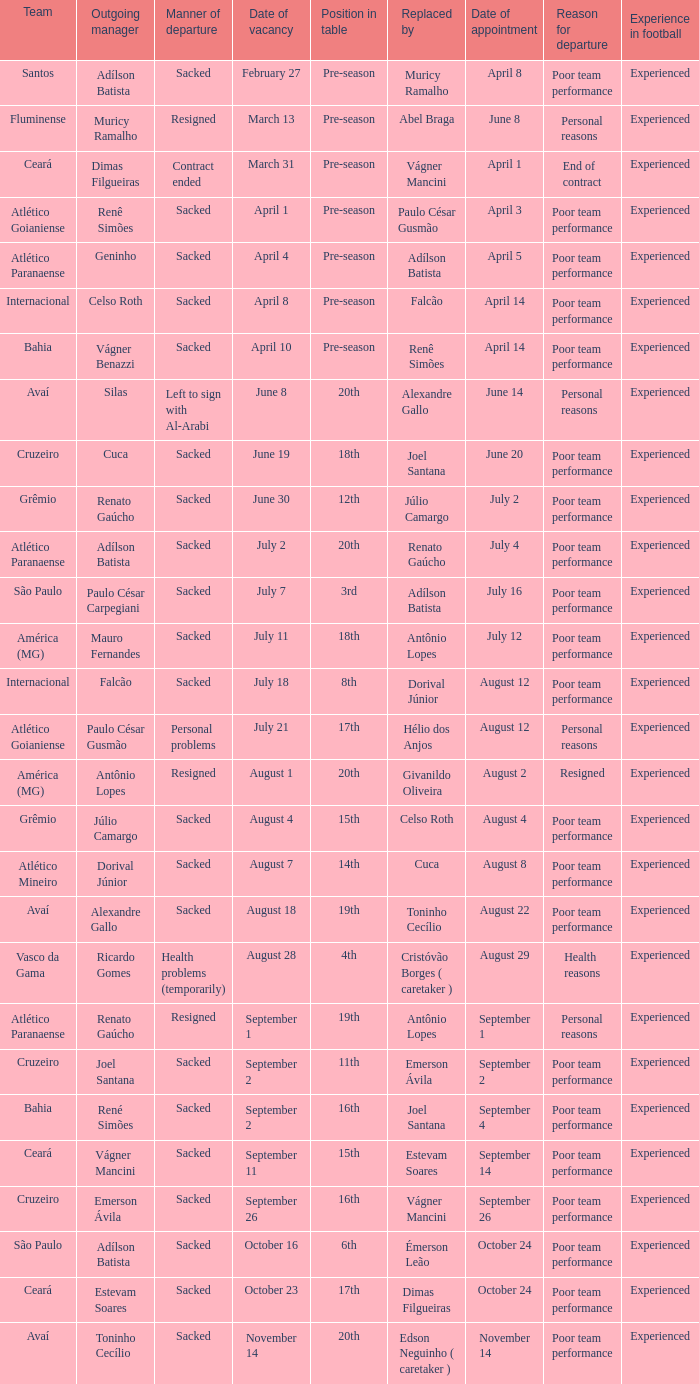What team hired Renato Gaúcho? Atlético Paranaense. Could you help me parse every detail presented in this table? {'header': ['Team', 'Outgoing manager', 'Manner of departure', 'Date of vacancy', 'Position in table', 'Replaced by', 'Date of appointment', 'Reason for departure', 'Experience in football'], 'rows': [['Santos', 'Adílson Batista', 'Sacked', 'February 27', 'Pre-season', 'Muricy Ramalho', 'April 8', 'Poor team performance', 'Experienced'], ['Fluminense', 'Muricy Ramalho', 'Resigned', 'March 13', 'Pre-season', 'Abel Braga', 'June 8', 'Personal reasons', 'Experienced'], ['Ceará', 'Dimas Filgueiras', 'Contract ended', 'March 31', 'Pre-season', 'Vágner Mancini', 'April 1', 'End of contract', 'Experienced'], ['Atlético Goianiense', 'Renê Simões', 'Sacked', 'April 1', 'Pre-season', 'Paulo César Gusmão', 'April 3', 'Poor team performance', 'Experienced'], ['Atlético Paranaense', 'Geninho', 'Sacked', 'April 4', 'Pre-season', 'Adílson Batista', 'April 5', 'Poor team performance', 'Experienced'], ['Internacional', 'Celso Roth', 'Sacked', 'April 8', 'Pre-season', 'Falcão', 'April 14', 'Poor team performance', 'Experienced'], ['Bahia', 'Vágner Benazzi', 'Sacked', 'April 10', 'Pre-season', 'Renê Simões', 'April 14', 'Poor team performance', 'Experienced'], ['Avaí', 'Silas', 'Left to sign with Al-Arabi', 'June 8', '20th', 'Alexandre Gallo', 'June 14', 'Personal reasons', 'Experienced'], ['Cruzeiro', 'Cuca', 'Sacked', 'June 19', '18th', 'Joel Santana', 'June 20', 'Poor team performance', 'Experienced'], ['Grêmio', 'Renato Gaúcho', 'Sacked', 'June 30', '12th', 'Júlio Camargo', 'July 2', 'Poor team performance', 'Experienced'], ['Atlético Paranaense', 'Adílson Batista', 'Sacked', 'July 2', '20th', 'Renato Gaúcho', 'July 4', 'Poor team performance', 'Experienced'], ['São Paulo', 'Paulo César Carpegiani', 'Sacked', 'July 7', '3rd', 'Adílson Batista', 'July 16', 'Poor team performance', 'Experienced'], ['América (MG)', 'Mauro Fernandes', 'Sacked', 'July 11', '18th', 'Antônio Lopes', 'July 12', 'Poor team performance', 'Experienced'], ['Internacional', 'Falcão', 'Sacked', 'July 18', '8th', 'Dorival Júnior', 'August 12', 'Poor team performance', 'Experienced'], ['Atlético Goianiense', 'Paulo César Gusmão', 'Personal problems', 'July 21', '17th', 'Hélio dos Anjos', 'August 12', 'Personal reasons', 'Experienced'], ['América (MG)', 'Antônio Lopes', 'Resigned', 'August 1', '20th', 'Givanildo Oliveira', 'August 2', 'Resigned', 'Experienced'], ['Grêmio', 'Júlio Camargo', 'Sacked', 'August 4', '15th', 'Celso Roth', 'August 4', 'Poor team performance', 'Experienced'], ['Atlético Mineiro', 'Dorival Júnior', 'Sacked', 'August 7', '14th', 'Cuca', 'August 8', 'Poor team performance', 'Experienced'], ['Avaí', 'Alexandre Gallo', 'Sacked', 'August 18', '19th', 'Toninho Cecílio', 'August 22', 'Poor team performance', 'Experienced'], ['Vasco da Gama', 'Ricardo Gomes', 'Health problems (temporarily)', 'August 28', '4th', 'Cristóvão Borges ( caretaker )', 'August 29', 'Health reasons', 'Experienced'], ['Atlético Paranaense', 'Renato Gaúcho', 'Resigned', 'September 1', '19th', 'Antônio Lopes', 'September 1', 'Personal reasons', 'Experienced'], ['Cruzeiro', 'Joel Santana', 'Sacked', 'September 2', '11th', 'Emerson Ávila', 'September 2', 'Poor team performance', 'Experienced'], ['Bahia', 'René Simões', 'Sacked', 'September 2', '16th', 'Joel Santana', 'September 4', 'Poor team performance', 'Experienced'], ['Ceará', 'Vágner Mancini', 'Sacked', 'September 11', '15th', 'Estevam Soares', 'September 14', 'Poor team performance', 'Experienced'], ['Cruzeiro', 'Emerson Ávila', 'Sacked', 'September 26', '16th', 'Vágner Mancini', 'September 26', 'Poor team performance', 'Experienced'], ['São Paulo', 'Adílson Batista', 'Sacked', 'October 16', '6th', 'Émerson Leão', 'October 24', 'Poor team performance', 'Experienced'], ['Ceará', 'Estevam Soares', 'Sacked', 'October 23', '17th', 'Dimas Filgueiras', 'October 24', 'Poor team performance', 'Experienced'], ['Avaí', 'Toninho Cecílio', 'Sacked', 'November 14', '20th', 'Edson Neguinho ( caretaker )', 'November 14', 'Poor team performance', 'Experienced']]} 